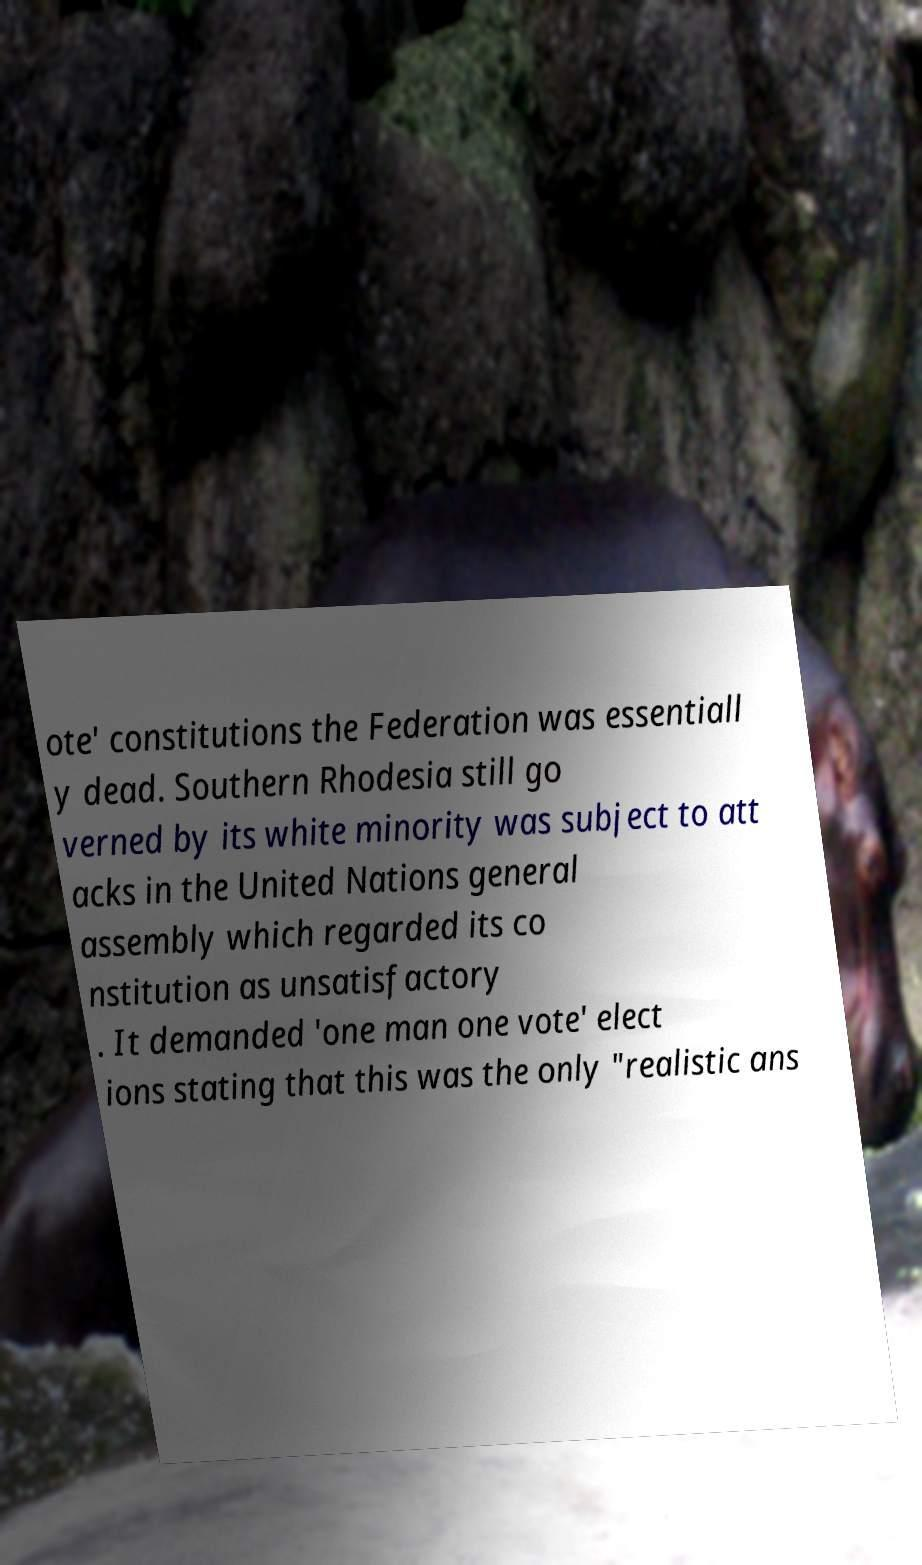Can you accurately transcribe the text from the provided image for me? ote' constitutions the Federation was essentiall y dead. Southern Rhodesia still go verned by its white minority was subject to att acks in the United Nations general assembly which regarded its co nstitution as unsatisfactory . It demanded 'one man one vote' elect ions stating that this was the only "realistic ans 